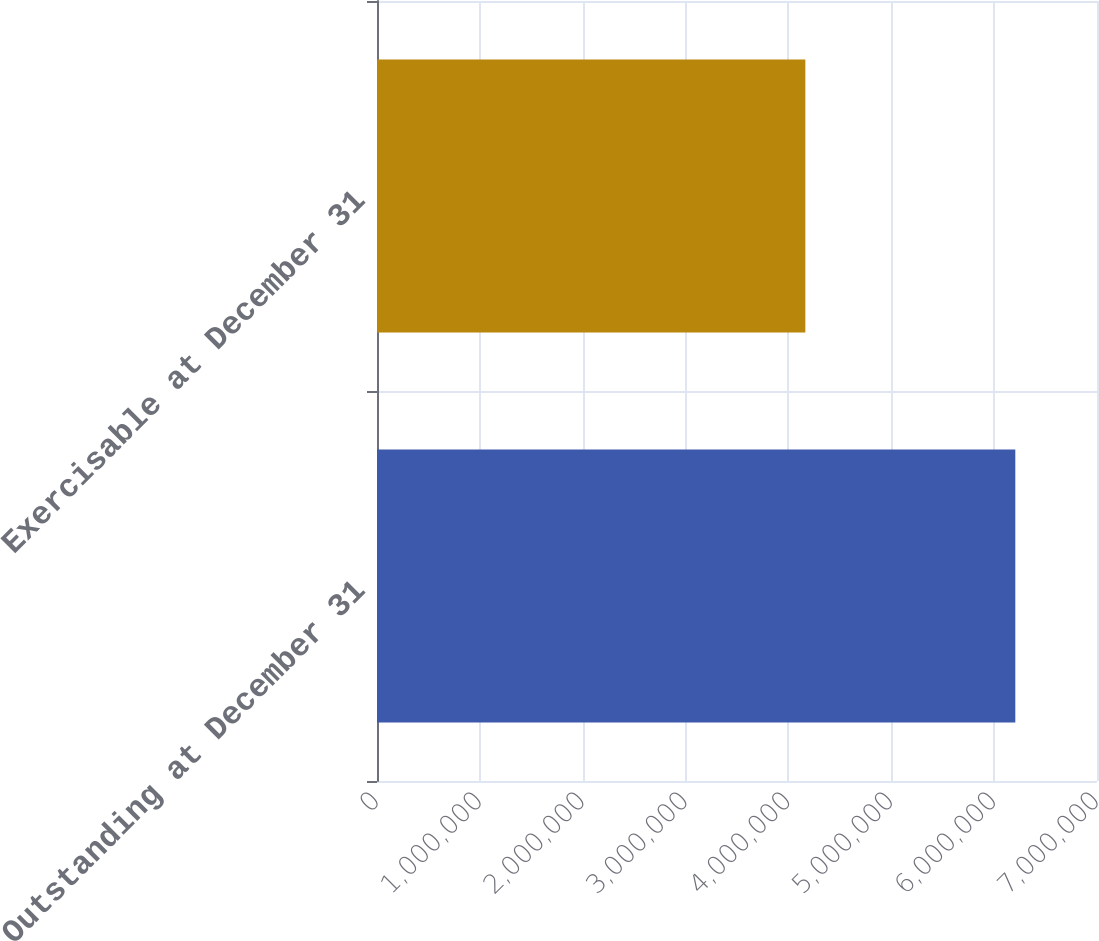<chart> <loc_0><loc_0><loc_500><loc_500><bar_chart><fcel>Outstanding at December 31<fcel>Exercisable at December 31<nl><fcel>6.20579e+06<fcel>4.16444e+06<nl></chart> 